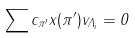Convert formula to latex. <formula><loc_0><loc_0><loc_500><loc_500>\sum c _ { \pi ^ { \prime } } x ( \pi ^ { \prime } ) v _ { \Lambda _ { i } } = 0</formula> 